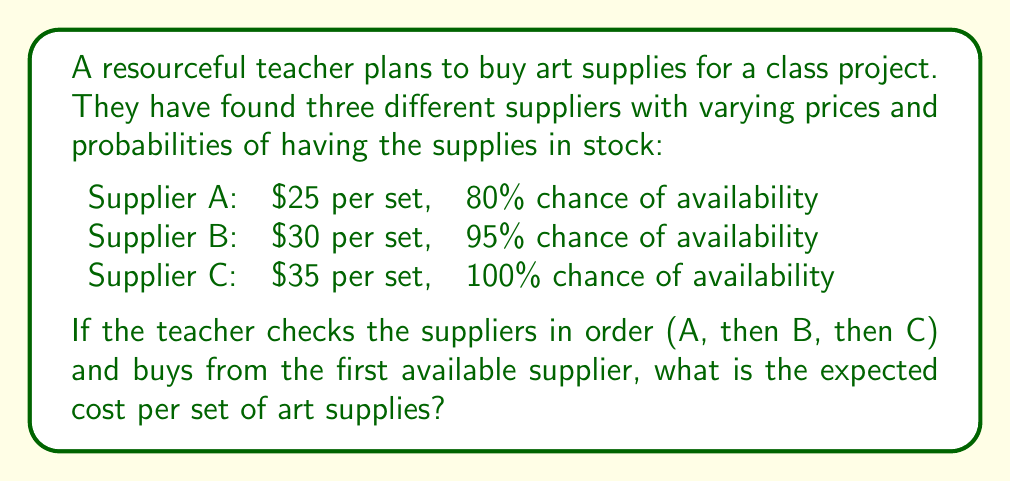What is the answer to this math problem? Let's approach this step-by-step:

1) First, we need to calculate the probability of buying from each supplier:

   P(A) = 0.80
   P(B) = (1 - 0.80) * 0.95 = 0.19
   P(C) = (1 - 0.80) * (1 - 0.95) = 0.01

2) Now, we can calculate the expected value using the formula:

   $$ E(X) = \sum_{i=1}^{n} x_i \cdot p_i $$

   Where $x_i$ is the cost from each supplier and $p_i$ is the probability of buying from that supplier.

3) Let's substitute our values:

   $$ E(X) = 25 \cdot 0.80 + 30 \cdot 0.19 + 35 \cdot 0.01 $$

4) Now, let's calculate:

   $$ E(X) = 20 + 5.70 + 0.35 = 26.05 $$

Therefore, the expected cost per set of art supplies is $26.05.
Answer: $26.05 